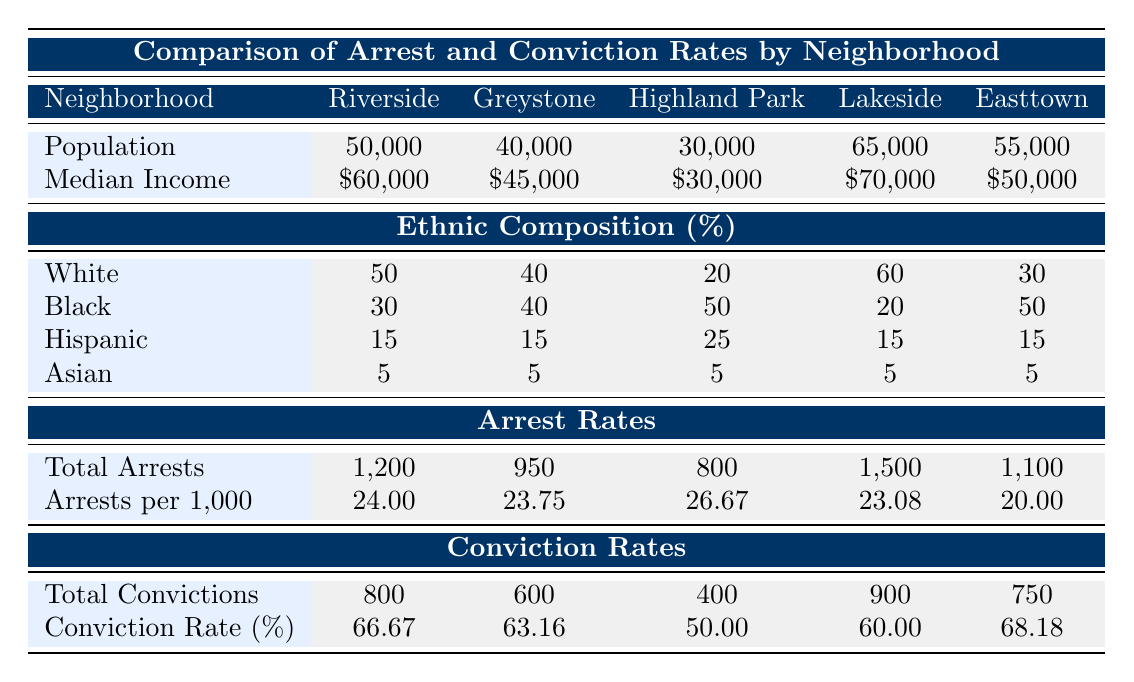What is the total number of arrests in Riverside? The table shows under the "Total Arrests" row for Riverside that there were 1,200 arrests made in that neighborhood.
Answer: 1,200 What is the conviction rate percentage in Lakeside? According to the table, Lakeside has a Conviction Rate percentage of 60.00 as listed under the Conviction Rates section.
Answer: 60.00 Which neighborhood has the highest arrest rate per 1,000 residents? Upon inspecting the "Arrests per 1,000" row, Highland Park shows the highest rate with 26.67 arrests per 1,000 residents.
Answer: Highland Park Is the ethnic composition of Highland Park majority Black? According to the Ethnic Composition row, Highland Park has 50% Black residents, which is the largest portion compared to the others listed in the table. Therefore, it can be considered a majority.
Answer: Yes What is the average conviction rate percentage across all neighborhoods? To find the average, we sum the conviction rates: (66.67 + 63.16 + 50.00 + 60.00 + 68.18) = 308.01. Dividing by 5 (the number of neighborhoods), the average conviction rate is 308.01 / 5 = 61.60.
Answer: 61.60 Which neighborhood has the lowest median income? The "Median Income" row shows that Highland Park has the lowest median income, listed at $30,000 compared to all other neighborhoods.
Answer: Highland Park Does Greystone have a higher conviction rate than Lakeside? Greystone has a conviction rate of 63.16%, while Lakeside's is 60.00%. Since 63.16% is greater than 60.00%, Greystone does indeed have a higher conviction rate.
Answer: Yes What is the ratio of total arrests to total convictions in Easttown? For Easttown, the total arrests are 1,100 and total convictions are 750. The ratio can be calculated as 1,100 / 750, which simplifies to approximately 1.47.
Answer: 1.47 